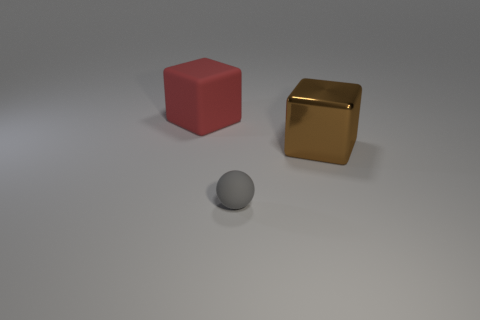How could this image be used in an educational context? This image could be used in educational materials to teach concepts such as geometry, where students can identify shapes and their properties, or art and design classes to discuss color theory, lighting, and the fundamentals of 3D rendering. 